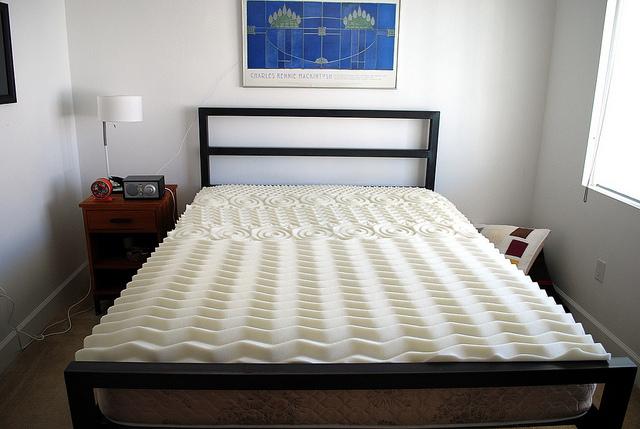Where is the picture?
Concise answer only. Bedroom. What is next to the bed on the left?
Concise answer only. Radio. What is the white thing on the bed used for?
Keep it brief. Comfort. 